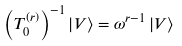Convert formula to latex. <formula><loc_0><loc_0><loc_500><loc_500>\left ( T _ { 0 } ^ { ( r ) } \right ) ^ { - 1 } \left | V \right \rangle = \omega ^ { r - 1 } \left | V \right \rangle</formula> 